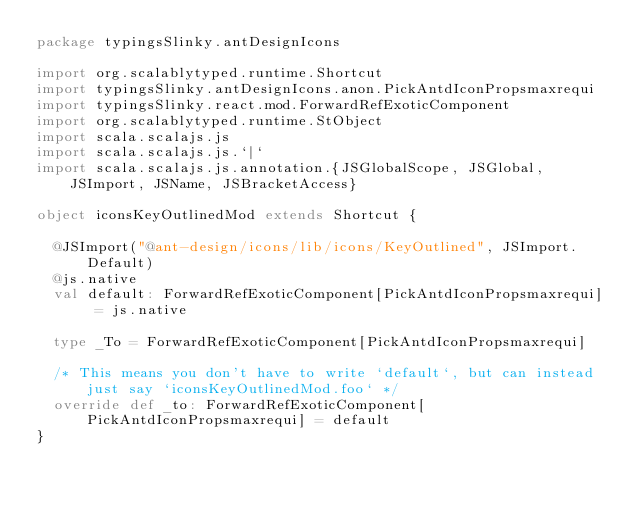Convert code to text. <code><loc_0><loc_0><loc_500><loc_500><_Scala_>package typingsSlinky.antDesignIcons

import org.scalablytyped.runtime.Shortcut
import typingsSlinky.antDesignIcons.anon.PickAntdIconPropsmaxrequi
import typingsSlinky.react.mod.ForwardRefExoticComponent
import org.scalablytyped.runtime.StObject
import scala.scalajs.js
import scala.scalajs.js.`|`
import scala.scalajs.js.annotation.{JSGlobalScope, JSGlobal, JSImport, JSName, JSBracketAccess}

object iconsKeyOutlinedMod extends Shortcut {
  
  @JSImport("@ant-design/icons/lib/icons/KeyOutlined", JSImport.Default)
  @js.native
  val default: ForwardRefExoticComponent[PickAntdIconPropsmaxrequi] = js.native
  
  type _To = ForwardRefExoticComponent[PickAntdIconPropsmaxrequi]
  
  /* This means you don't have to write `default`, but can instead just say `iconsKeyOutlinedMod.foo` */
  override def _to: ForwardRefExoticComponent[PickAntdIconPropsmaxrequi] = default
}
</code> 